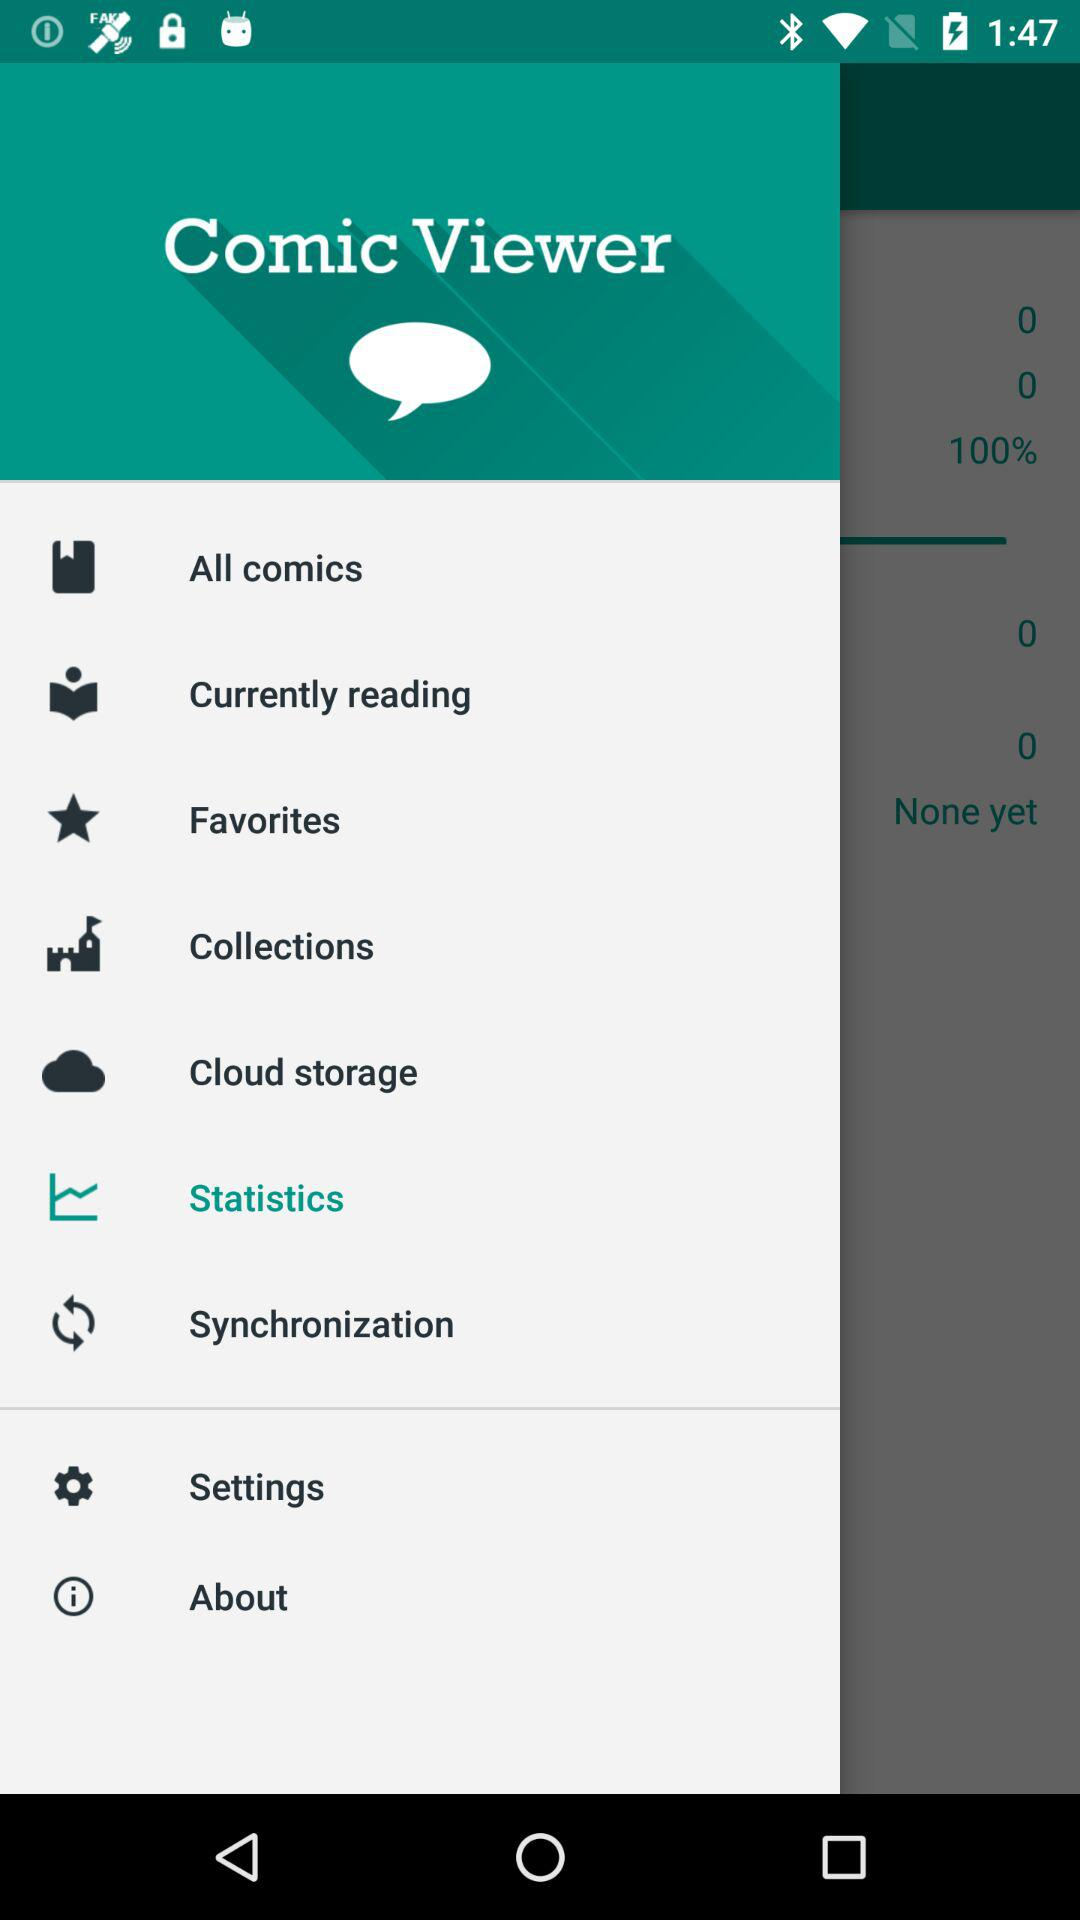What is the name of the application? The application name is "Comic Viewer". 